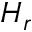<formula> <loc_0><loc_0><loc_500><loc_500>H _ { r }</formula> 